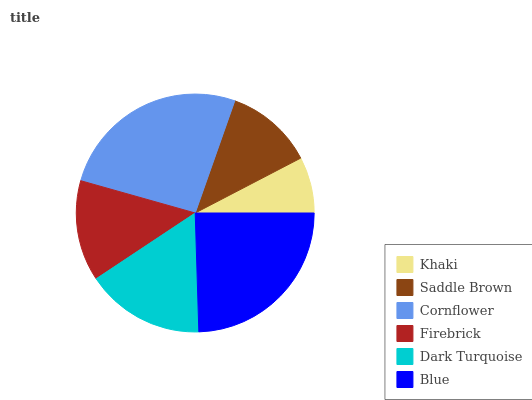Is Khaki the minimum?
Answer yes or no. Yes. Is Cornflower the maximum?
Answer yes or no. Yes. Is Saddle Brown the minimum?
Answer yes or no. No. Is Saddle Brown the maximum?
Answer yes or no. No. Is Saddle Brown greater than Khaki?
Answer yes or no. Yes. Is Khaki less than Saddle Brown?
Answer yes or no. Yes. Is Khaki greater than Saddle Brown?
Answer yes or no. No. Is Saddle Brown less than Khaki?
Answer yes or no. No. Is Dark Turquoise the high median?
Answer yes or no. Yes. Is Firebrick the low median?
Answer yes or no. Yes. Is Firebrick the high median?
Answer yes or no. No. Is Dark Turquoise the low median?
Answer yes or no. No. 